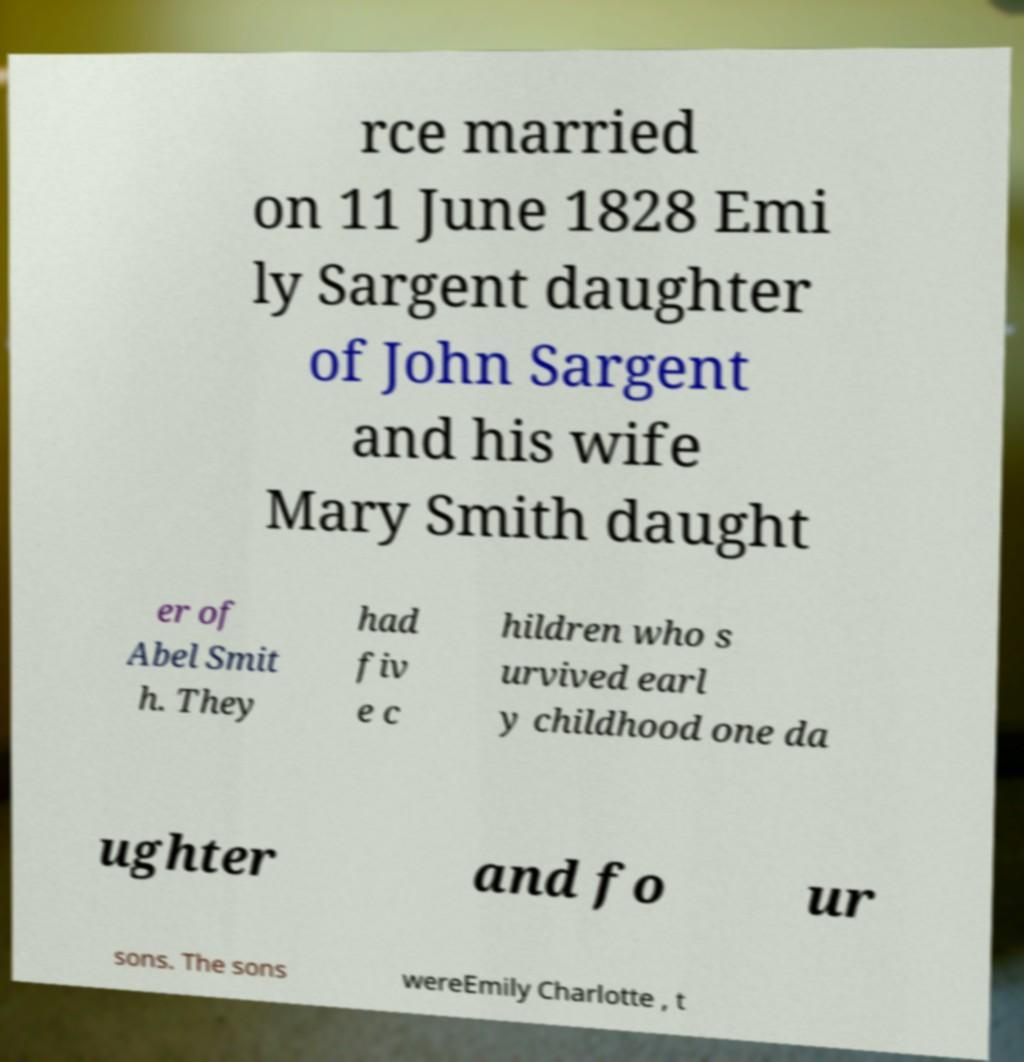Could you extract and type out the text from this image? rce married on 11 June 1828 Emi ly Sargent daughter of John Sargent and his wife Mary Smith daught er of Abel Smit h. They had fiv e c hildren who s urvived earl y childhood one da ughter and fo ur sons. The sons wereEmily Charlotte , t 